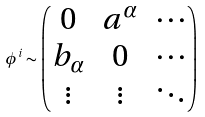Convert formula to latex. <formula><loc_0><loc_0><loc_500><loc_500>\phi ^ { i } \sim \begin{pmatrix} 0 & a ^ { \alpha } & \cdots \\ b _ { \alpha } & 0 & \cdots \\ \vdots & \vdots & \ddots \end{pmatrix}</formula> 